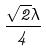<formula> <loc_0><loc_0><loc_500><loc_500>\frac { \sqrt { 2 } \lambda } { 4 }</formula> 